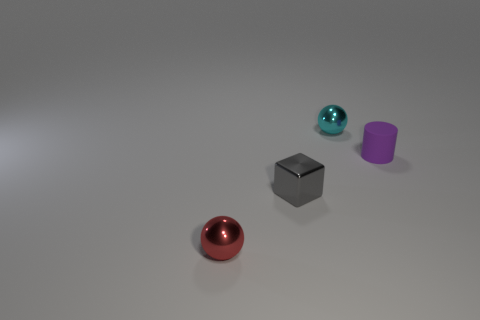The cyan object that is the same shape as the tiny red metallic object is what size?
Ensure brevity in your answer.  Small. What number of things are either tiny things on the left side of the small cylinder or tiny balls that are behind the gray metallic object?
Offer a very short reply. 3. What is the size of the thing that is both behind the tiny gray thing and on the left side of the rubber cylinder?
Make the answer very short. Small. Do the purple matte object and the metal thing on the left side of the tiny gray metallic object have the same shape?
Offer a terse response. No. What number of objects are small metal balls in front of the small cyan ball or tiny rubber objects?
Offer a very short reply. 2. Do the cube and the thing that is to the right of the tiny cyan ball have the same material?
Your answer should be compact. No. The purple matte object that is on the right side of the metal sphere left of the tiny cyan metal thing is what shape?
Provide a short and direct response. Cylinder. Is the color of the matte cylinder the same as the metal ball that is behind the small gray metallic cube?
Make the answer very short. No. Are there any other things that have the same material as the tiny cyan object?
Offer a very short reply. Yes. The cyan thing is what shape?
Your answer should be compact. Sphere. 